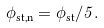<formula> <loc_0><loc_0><loc_500><loc_500>\phi _ { \text {st,n} } = \phi _ { \text {st} } / 5 .</formula> 